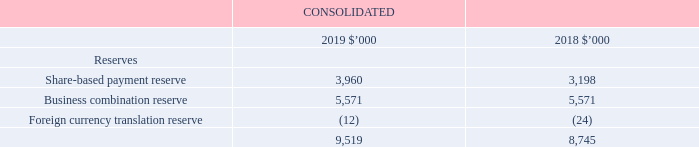4.2 Equity (continued)
Share buy-back
A buy-back is the purchase by a company of its existing shares. Refer to note 4.3 for further details.
Share-based payment reserve
This reserve records the value of shares under the Long Term Incentive Plan, and historical Employee and CEO Share Option plans offered to the CEO, Executives and employees as part of their remuneration. Refer to note 5.2 for further details of these plans.
Business combination reserve
The internal group restructure performed in the 2007 financial year, which interposed the holding company, iSelect Limited, into the consolidated group was exempted by AASB 3 Business Combinations as it precludes entities or businesses under common control. The carry-over basis method of accounting was used for the restructuring of the iSelect Group. As such, the assets and liabilities were reflected at their carrying amounts. No adjustments were made to reflect fair values, or recognise any new assets or liabilities. No goodwill was recognised as a result of the combination and any difference between the consideration paid and the ‘equity’ acquired was reflected within equity as an equity reserve titled “Business Combination Reserve”.
Foreign currency translation reserve
Refer to Note 1.5 for further details.
What are the components of reserves? Share-based payment reserve, business combination reserve, foreign currency translation reserve. Which method of accounting was used for the restructuring of the iSelect Group? Carry-over basis method of accounting. What is a buy-back? The purchase by a company of its existing shares. In which year is the share-based payment reserve higher? Find the year with the higiher share-based payment reserve
Answer: 2019. What is the change in the Business combination reserve between 2018 and 2019?
Answer scale should be: thousand. 5,571-5,571
Answer: 0. What is the percentage change in the total reserves from 2018 to 2019?
Answer scale should be: percent. (9,519-8,745)/8,745
Answer: 8.85. 